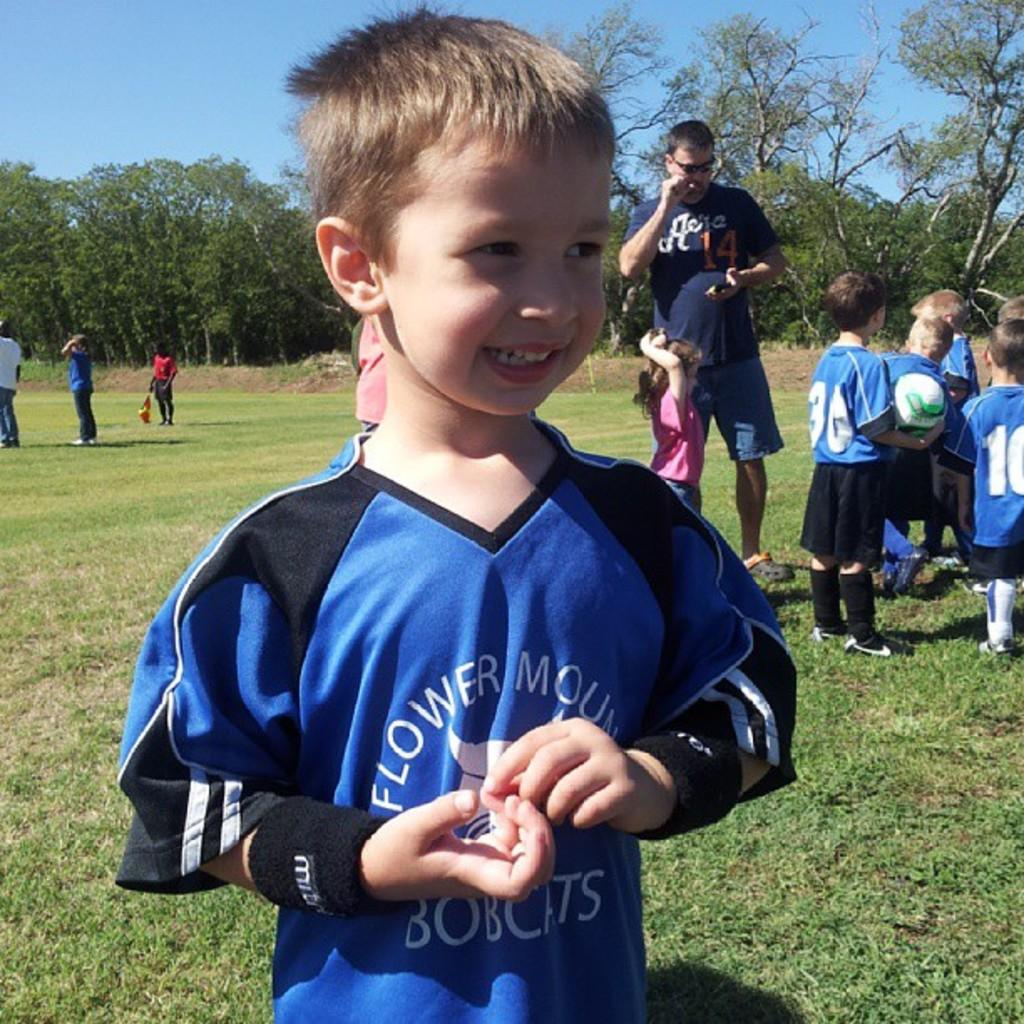<image>
Render a clear and concise summary of the photo. A small boy wearing a blue shirt, the word Flower is visible on the front. 